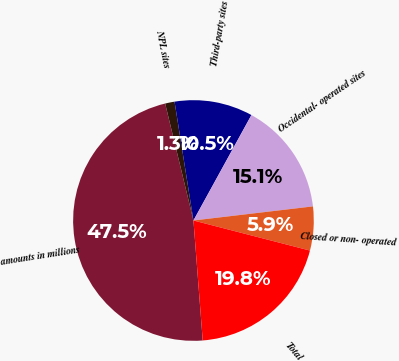<chart> <loc_0><loc_0><loc_500><loc_500><pie_chart><fcel>amounts in millions<fcel>NPL sites<fcel>Third-party sites<fcel>Occidental- operated sites<fcel>Closed or non- operated<fcel>Total<nl><fcel>47.45%<fcel>1.27%<fcel>10.51%<fcel>15.13%<fcel>5.89%<fcel>19.75%<nl></chart> 